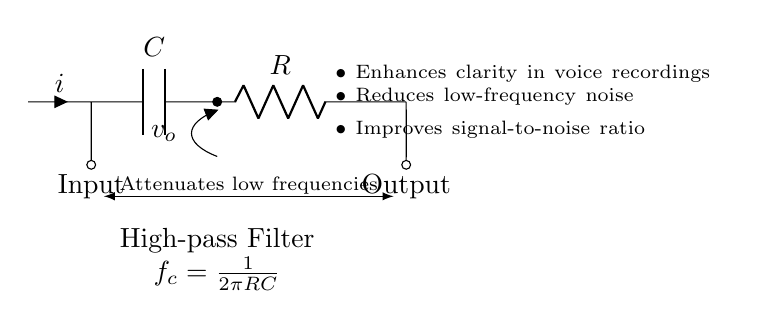What are the components in the circuit? The circuit contains a capacitor labeled C and a resistor labeled R, which are the key components of a high-pass filter.
Answer: capacitor and resistor What does the capacitor do in this high-pass filter? The capacitor blocks low-frequency signals, allowing high-frequency signals to pass through, hence improving the voice clarity by filtering out unwanted noise.
Answer: Blocks low frequencies What is the cutoff frequency formula for this circuit? The cutoff frequency, denoted as fc, is calculated using the formula fc = 1/(2πRC), where R is the resistance and C is the capacitance.
Answer: fc = 1/(2πRC) What is the function of the high-pass filter in audio systems? The high-pass filter enhances clarity in voice recordings by attenuating low-frequency noise, which allows the primary audio signal (voice) to be clearer.
Answer: Enhances voice clarity How does this circuit improve the signal-to-noise ratio? This circuit improves the signal-to-noise ratio by reducing low-frequency noise that can interfere with the desired audio signal, making the desired sound more prominent.
Answer: Reduces low-frequency noise What is the significance of having the output after the resistor in this circuit? Placing the output after the resistor ensures that only the filtered, high-frequency signal is passed on, which is essential for maintaining audio clarity.
Answer: Ensures filtered signal output 